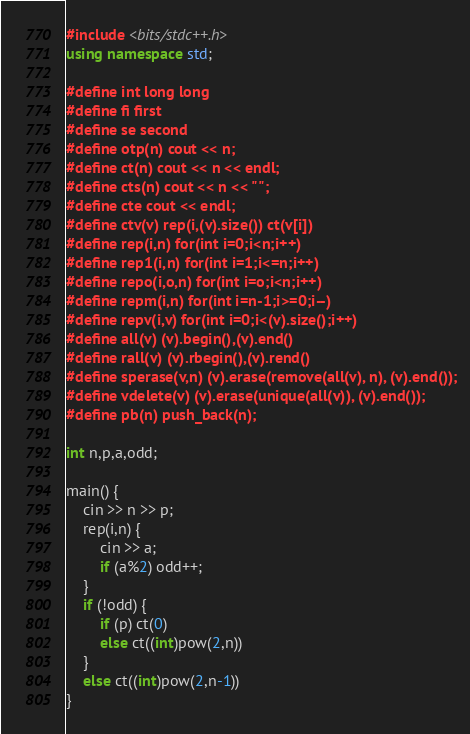Convert code to text. <code><loc_0><loc_0><loc_500><loc_500><_C++_>#include <bits/stdc++.h>
using namespace std;

#define int long long
#define fi first
#define se second
#define otp(n) cout << n;
#define ct(n) cout << n << endl;
#define cts(n) cout << n << " ";
#define cte cout << endl;
#define ctv(v) rep(i,(v).size()) ct(v[i])
#define rep(i,n) for(int i=0;i<n;i++)
#define rep1(i,n) for(int i=1;i<=n;i++)
#define repo(i,o,n) for(int i=o;i<n;i++)
#define repm(i,n) for(int i=n-1;i>=0;i--)
#define repv(i,v) for(int i=0;i<(v).size();i++)
#define all(v) (v).begin(),(v).end()
#define rall(v) (v).rbegin(),(v).rend()
#define sperase(v,n) (v).erase(remove(all(v), n), (v).end());
#define vdelete(v) (v).erase(unique(all(v)), (v).end());
#define pb(n) push_back(n);

int n,p,a,odd;

main() {
    cin >> n >> p;
    rep(i,n) {
        cin >> a;
        if (a%2) odd++;
    }
    if (!odd) {
        if (p) ct(0)
        else ct((int)pow(2,n))
    }
    else ct((int)pow(2,n-1))
}
</code> 